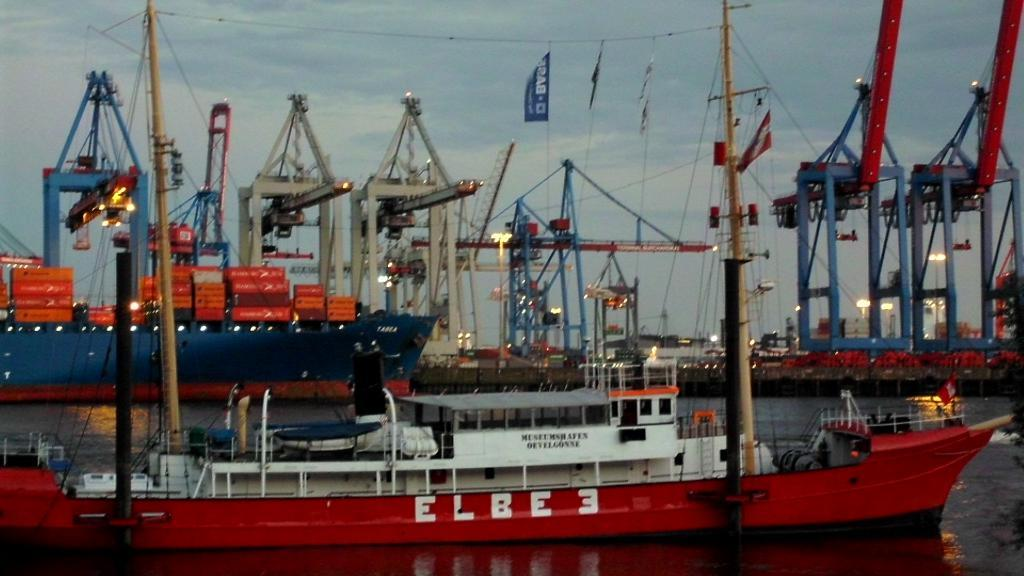What is on the water in the image? There are ships on the water in the image. What can be seen on the ships? There are containers on the ships. What can be seen in the background of the image? There are cranes, lights, and cables visible in the background of the image. What type of print can be seen on the thunder in the image? There is no print or thunder present in the image; it features ships on the water with containers, and a background with cranes, lights, and cables. 